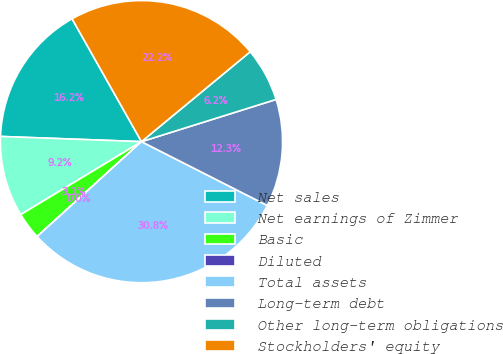Convert chart to OTSL. <chart><loc_0><loc_0><loc_500><loc_500><pie_chart><fcel>Net sales<fcel>Net earnings of Zimmer<fcel>Basic<fcel>Diluted<fcel>Total assets<fcel>Long-term debt<fcel>Other long-term obligations<fcel>Stockholders' equity<nl><fcel>16.23%<fcel>9.24%<fcel>3.09%<fcel>0.01%<fcel>30.77%<fcel>12.31%<fcel>6.16%<fcel>22.19%<nl></chart> 